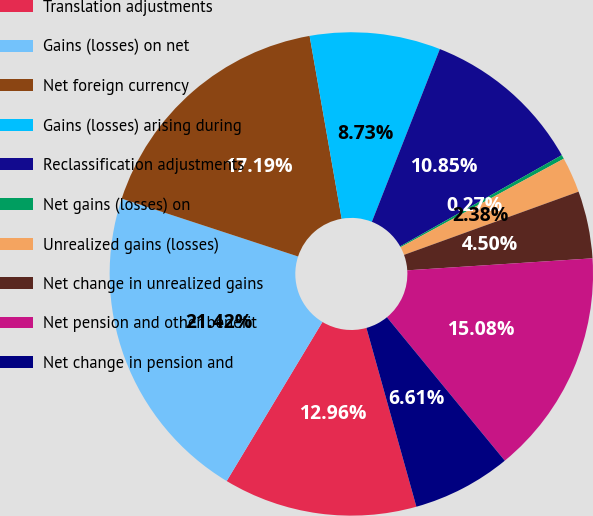Convert chart. <chart><loc_0><loc_0><loc_500><loc_500><pie_chart><fcel>Translation adjustments<fcel>Gains (losses) on net<fcel>Net foreign currency<fcel>Gains (losses) arising during<fcel>Reclassification adjustments<fcel>Net gains (losses) on<fcel>Unrealized gains (losses)<fcel>Net change in unrealized gains<fcel>Net pension and other benefit<fcel>Net change in pension and<nl><fcel>12.96%<fcel>21.42%<fcel>17.19%<fcel>8.73%<fcel>10.85%<fcel>0.27%<fcel>2.38%<fcel>4.5%<fcel>15.08%<fcel>6.61%<nl></chart> 